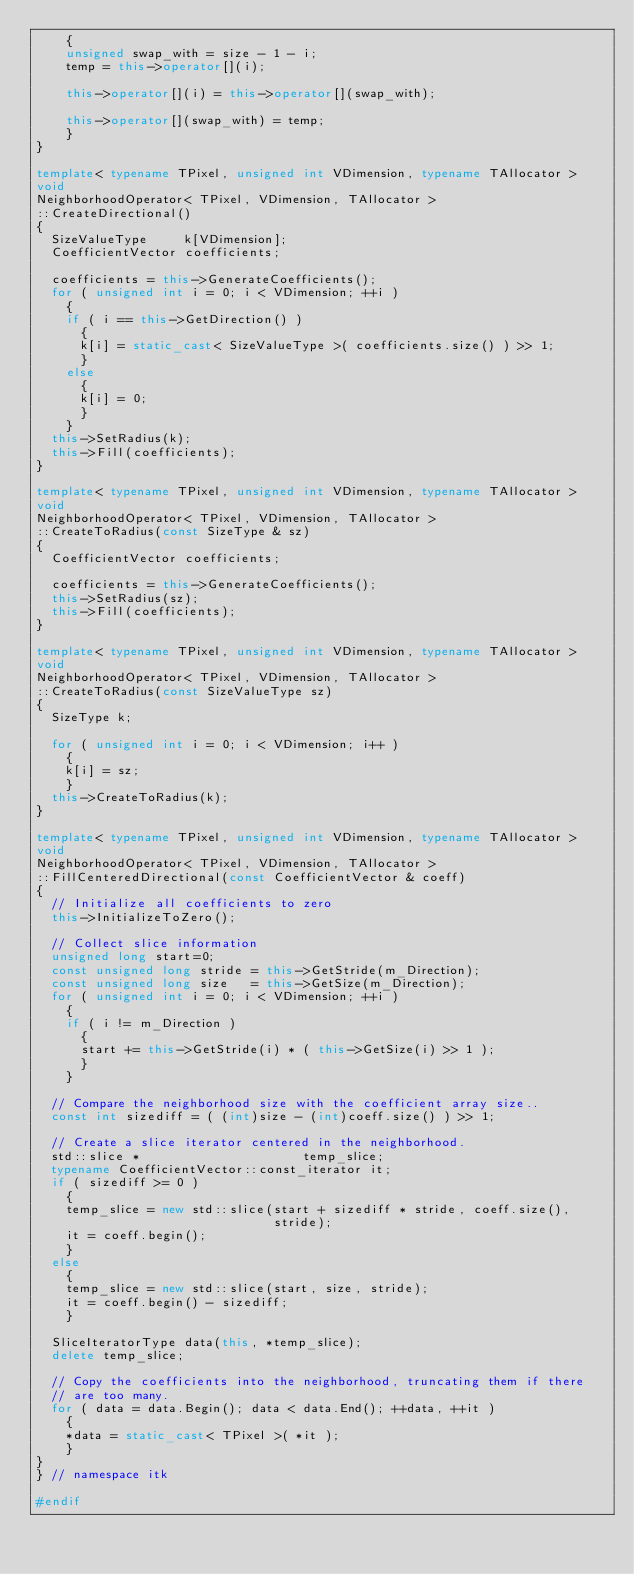<code> <loc_0><loc_0><loc_500><loc_500><_C++_>    {
    unsigned swap_with = size - 1 - i;
    temp = this->operator[](i);

    this->operator[](i) = this->operator[](swap_with);

    this->operator[](swap_with) = temp;
    }
}

template< typename TPixel, unsigned int VDimension, typename TAllocator >
void
NeighborhoodOperator< TPixel, VDimension, TAllocator >
::CreateDirectional()
{
  SizeValueType     k[VDimension];
  CoefficientVector coefficients;

  coefficients = this->GenerateCoefficients();
  for ( unsigned int i = 0; i < VDimension; ++i )
    {
    if ( i == this->GetDirection() )
      {
      k[i] = static_cast< SizeValueType >( coefficients.size() ) >> 1;
      }
    else
      {
      k[i] = 0;
      }
    }
  this->SetRadius(k);
  this->Fill(coefficients);
}

template< typename TPixel, unsigned int VDimension, typename TAllocator >
void
NeighborhoodOperator< TPixel, VDimension, TAllocator >
::CreateToRadius(const SizeType & sz)
{
  CoefficientVector coefficients;

  coefficients = this->GenerateCoefficients();
  this->SetRadius(sz);
  this->Fill(coefficients);
}

template< typename TPixel, unsigned int VDimension, typename TAllocator >
void
NeighborhoodOperator< TPixel, VDimension, TAllocator >
::CreateToRadius(const SizeValueType sz)
{
  SizeType k;

  for ( unsigned int i = 0; i < VDimension; i++ )
    {
    k[i] = sz;
    }
  this->CreateToRadius(k);
}

template< typename TPixel, unsigned int VDimension, typename TAllocator >
void
NeighborhoodOperator< TPixel, VDimension, TAllocator >
::FillCenteredDirectional(const CoefficientVector & coeff)
{
  // Initialize all coefficients to zero
  this->InitializeToZero();

  // Collect slice information
  unsigned long start=0;
  const unsigned long stride = this->GetStride(m_Direction);
  const unsigned long size   = this->GetSize(m_Direction);
  for ( unsigned int i = 0; i < VDimension; ++i )
    {
    if ( i != m_Direction )
      {
      start += this->GetStride(i) * ( this->GetSize(i) >> 1 );
      }
    }

  // Compare the neighborhood size with the coefficient array size..
  const int sizediff = ( (int)size - (int)coeff.size() ) >> 1;

  // Create a slice iterator centered in the neighborhood.
  std::slice *                      temp_slice;
  typename CoefficientVector::const_iterator it;
  if ( sizediff >= 0 )
    {
    temp_slice = new std::slice(start + sizediff * stride, coeff.size(),
                                stride);
    it = coeff.begin();
    }
  else
    {
    temp_slice = new std::slice(start, size, stride);
    it = coeff.begin() - sizediff;
    }

  SliceIteratorType data(this, *temp_slice);
  delete temp_slice;

  // Copy the coefficients into the neighborhood, truncating them if there
  // are too many.
  for ( data = data.Begin(); data < data.End(); ++data, ++it )
    {
    *data = static_cast< TPixel >( *it );
    }
}
} // namespace itk

#endif
</code> 